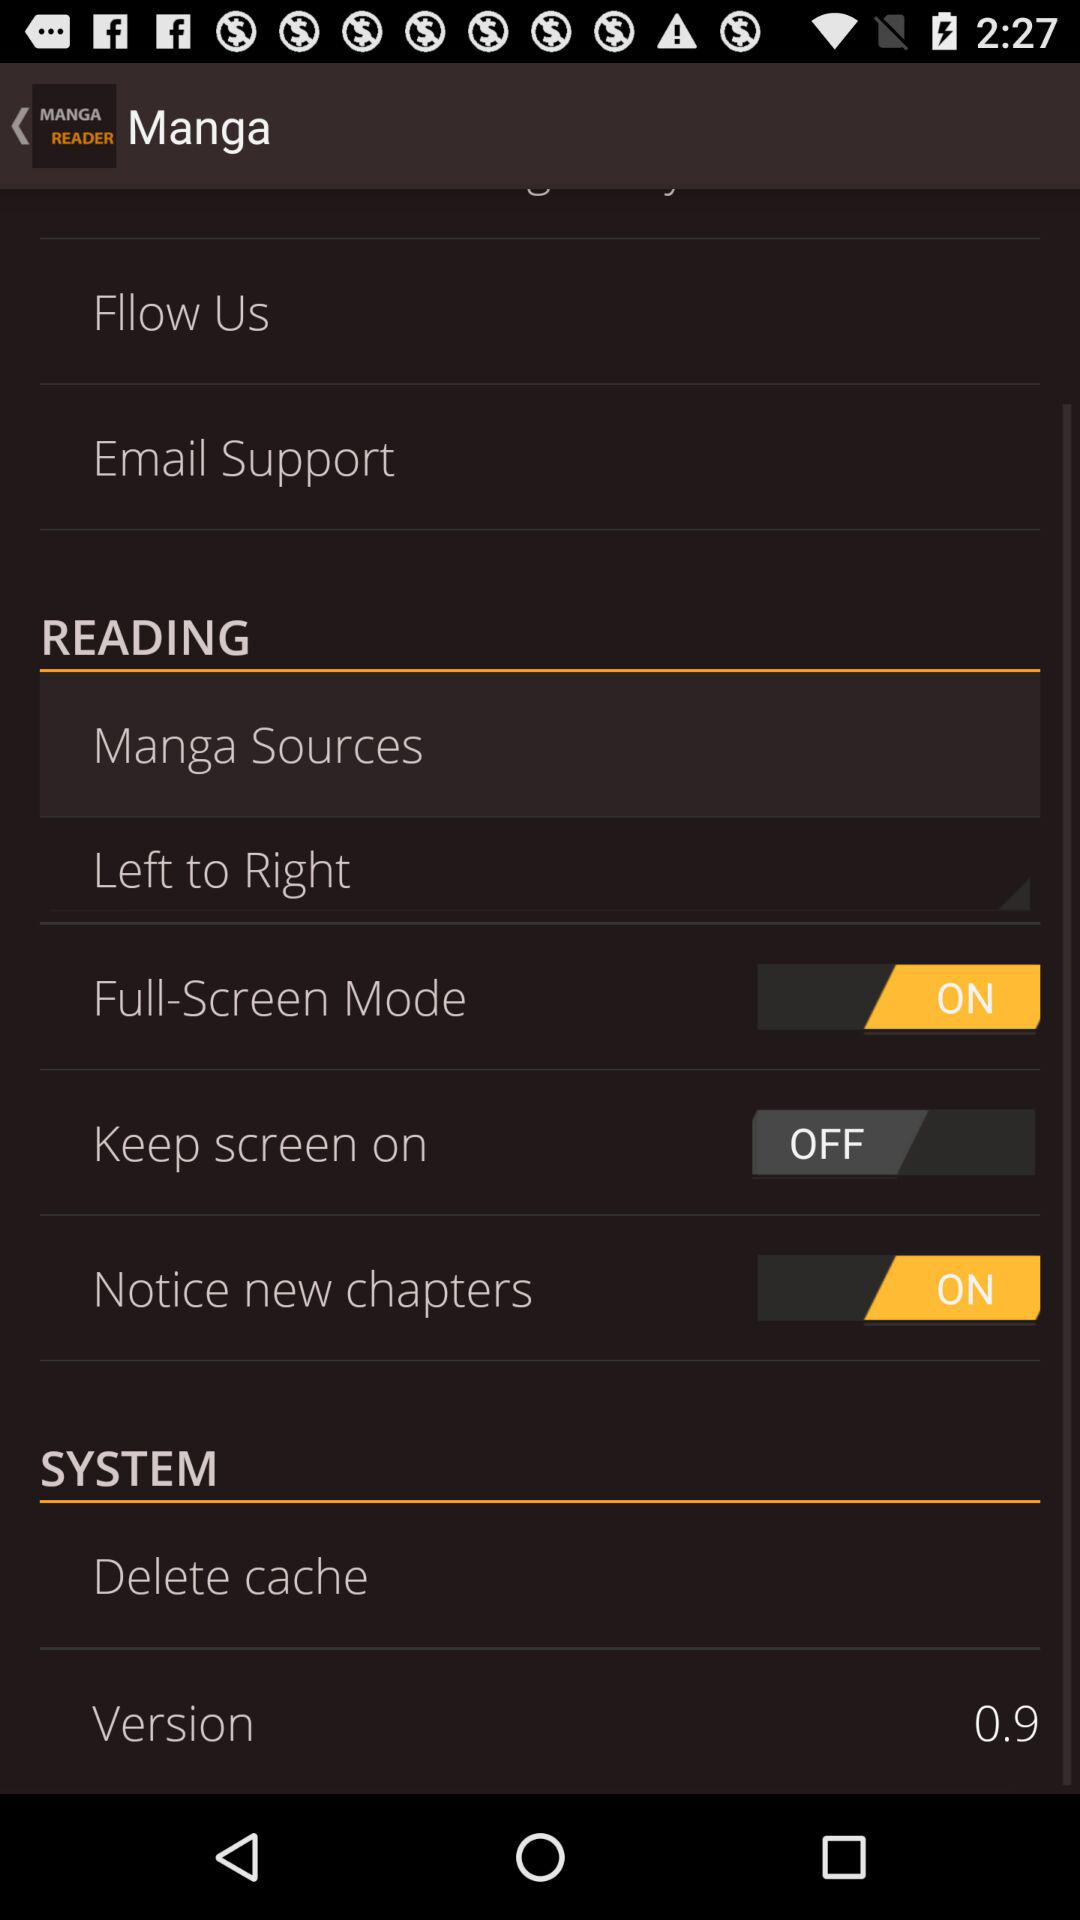How many items can be found in the SYSTEM section?
Answer the question using a single word or phrase. 2 